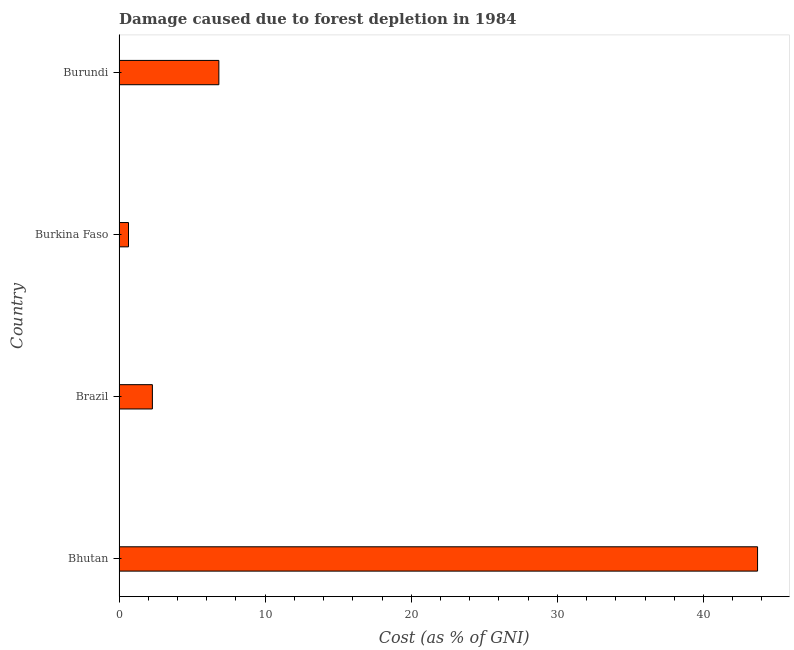Does the graph contain any zero values?
Your answer should be very brief. No. Does the graph contain grids?
Give a very brief answer. No. What is the title of the graph?
Provide a short and direct response. Damage caused due to forest depletion in 1984. What is the label or title of the X-axis?
Offer a very short reply. Cost (as % of GNI). What is the damage caused due to forest depletion in Bhutan?
Provide a short and direct response. 43.7. Across all countries, what is the maximum damage caused due to forest depletion?
Your response must be concise. 43.7. Across all countries, what is the minimum damage caused due to forest depletion?
Your response must be concise. 0.65. In which country was the damage caused due to forest depletion maximum?
Your response must be concise. Bhutan. In which country was the damage caused due to forest depletion minimum?
Your answer should be compact. Burkina Faso. What is the sum of the damage caused due to forest depletion?
Your response must be concise. 53.46. What is the difference between the damage caused due to forest depletion in Burkina Faso and Burundi?
Keep it short and to the point. -6.18. What is the average damage caused due to forest depletion per country?
Offer a very short reply. 13.36. What is the median damage caused due to forest depletion?
Make the answer very short. 4.56. In how many countries, is the damage caused due to forest depletion greater than 12 %?
Keep it short and to the point. 1. What is the ratio of the damage caused due to forest depletion in Bhutan to that in Brazil?
Offer a very short reply. 19.15. Is the damage caused due to forest depletion in Bhutan less than that in Burundi?
Your answer should be compact. No. Is the difference between the damage caused due to forest depletion in Brazil and Burkina Faso greater than the difference between any two countries?
Give a very brief answer. No. What is the difference between the highest and the second highest damage caused due to forest depletion?
Your response must be concise. 36.87. What is the difference between the highest and the lowest damage caused due to forest depletion?
Provide a short and direct response. 43.05. In how many countries, is the damage caused due to forest depletion greater than the average damage caused due to forest depletion taken over all countries?
Give a very brief answer. 1. How many bars are there?
Provide a short and direct response. 4. Are all the bars in the graph horizontal?
Your response must be concise. Yes. What is the Cost (as % of GNI) of Bhutan?
Your response must be concise. 43.7. What is the Cost (as % of GNI) in Brazil?
Provide a short and direct response. 2.28. What is the Cost (as % of GNI) in Burkina Faso?
Ensure brevity in your answer.  0.65. What is the Cost (as % of GNI) of Burundi?
Offer a very short reply. 6.83. What is the difference between the Cost (as % of GNI) in Bhutan and Brazil?
Keep it short and to the point. 41.42. What is the difference between the Cost (as % of GNI) in Bhutan and Burkina Faso?
Offer a terse response. 43.05. What is the difference between the Cost (as % of GNI) in Bhutan and Burundi?
Your answer should be compact. 36.87. What is the difference between the Cost (as % of GNI) in Brazil and Burkina Faso?
Provide a short and direct response. 1.64. What is the difference between the Cost (as % of GNI) in Brazil and Burundi?
Offer a very short reply. -4.55. What is the difference between the Cost (as % of GNI) in Burkina Faso and Burundi?
Keep it short and to the point. -6.18. What is the ratio of the Cost (as % of GNI) in Bhutan to that in Brazil?
Offer a very short reply. 19.15. What is the ratio of the Cost (as % of GNI) in Bhutan to that in Burkina Faso?
Offer a terse response. 67.62. What is the ratio of the Cost (as % of GNI) in Bhutan to that in Burundi?
Offer a very short reply. 6.4. What is the ratio of the Cost (as % of GNI) in Brazil to that in Burkina Faso?
Ensure brevity in your answer.  3.53. What is the ratio of the Cost (as % of GNI) in Brazil to that in Burundi?
Ensure brevity in your answer.  0.33. What is the ratio of the Cost (as % of GNI) in Burkina Faso to that in Burundi?
Give a very brief answer. 0.1. 